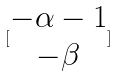<formula> <loc_0><loc_0><loc_500><loc_500>[ \begin{matrix} - \alpha - 1 \\ - \beta \end{matrix} ]</formula> 